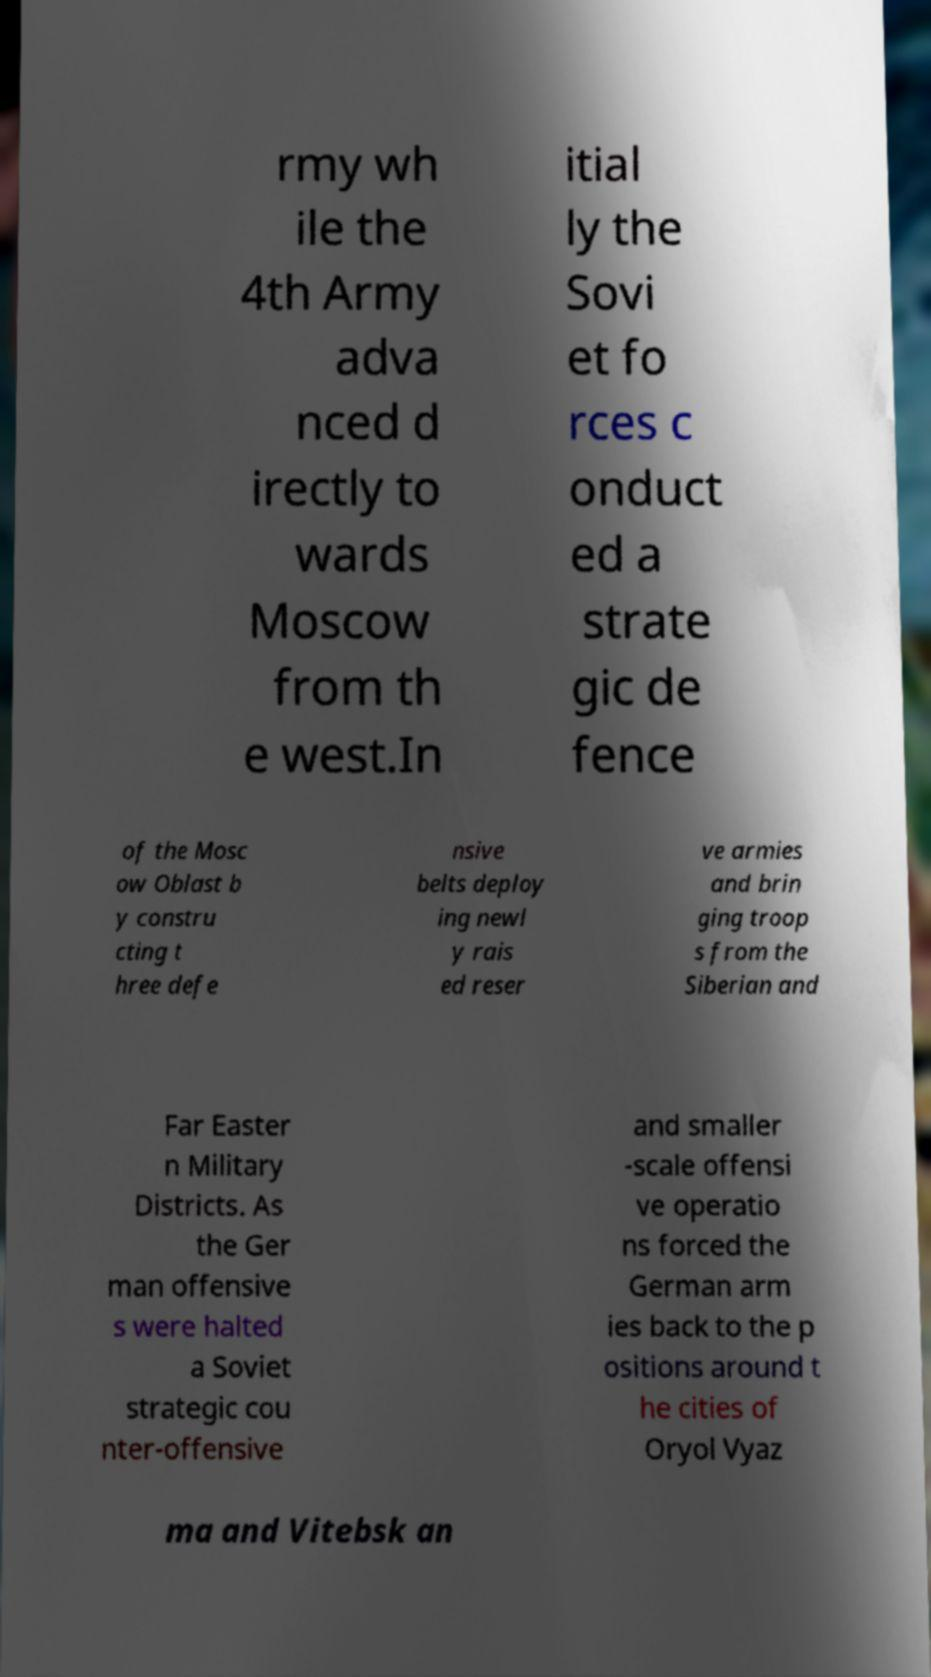There's text embedded in this image that I need extracted. Can you transcribe it verbatim? rmy wh ile the 4th Army adva nced d irectly to wards Moscow from th e west.In itial ly the Sovi et fo rces c onduct ed a strate gic de fence of the Mosc ow Oblast b y constru cting t hree defe nsive belts deploy ing newl y rais ed reser ve armies and brin ging troop s from the Siberian and Far Easter n Military Districts. As the Ger man offensive s were halted a Soviet strategic cou nter-offensive and smaller -scale offensi ve operatio ns forced the German arm ies back to the p ositions around t he cities of Oryol Vyaz ma and Vitebsk an 